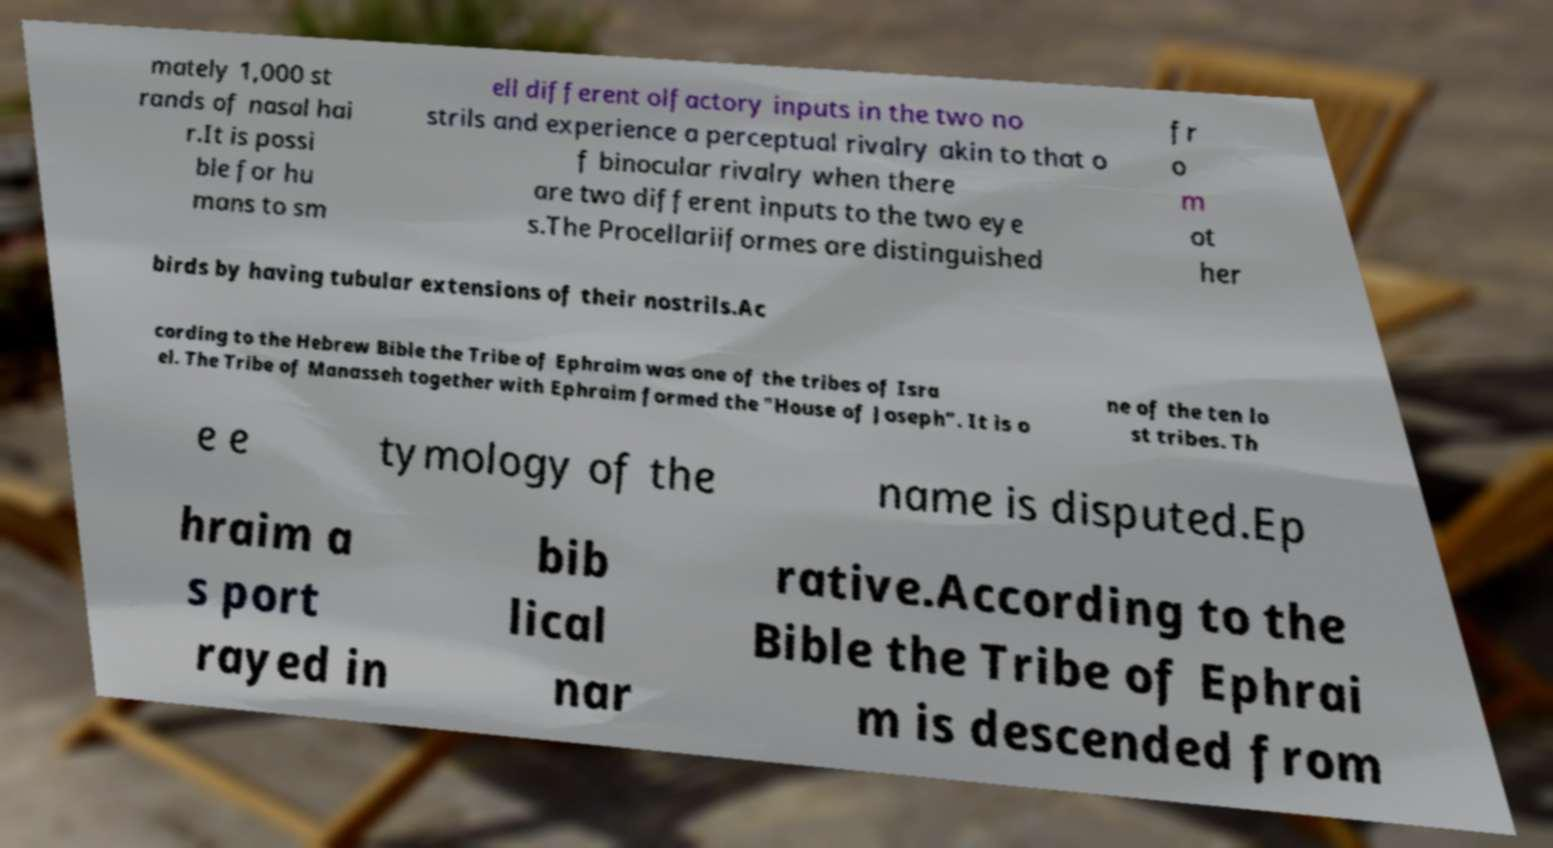Please identify and transcribe the text found in this image. mately 1,000 st rands of nasal hai r.It is possi ble for hu mans to sm ell different olfactory inputs in the two no strils and experience a perceptual rivalry akin to that o f binocular rivalry when there are two different inputs to the two eye s.The Procellariiformes are distinguished fr o m ot her birds by having tubular extensions of their nostrils.Ac cording to the Hebrew Bible the Tribe of Ephraim was one of the tribes of Isra el. The Tribe of Manasseh together with Ephraim formed the "House of Joseph". It is o ne of the ten lo st tribes. Th e e tymology of the name is disputed.Ep hraim a s port rayed in bib lical nar rative.According to the Bible the Tribe of Ephrai m is descended from 